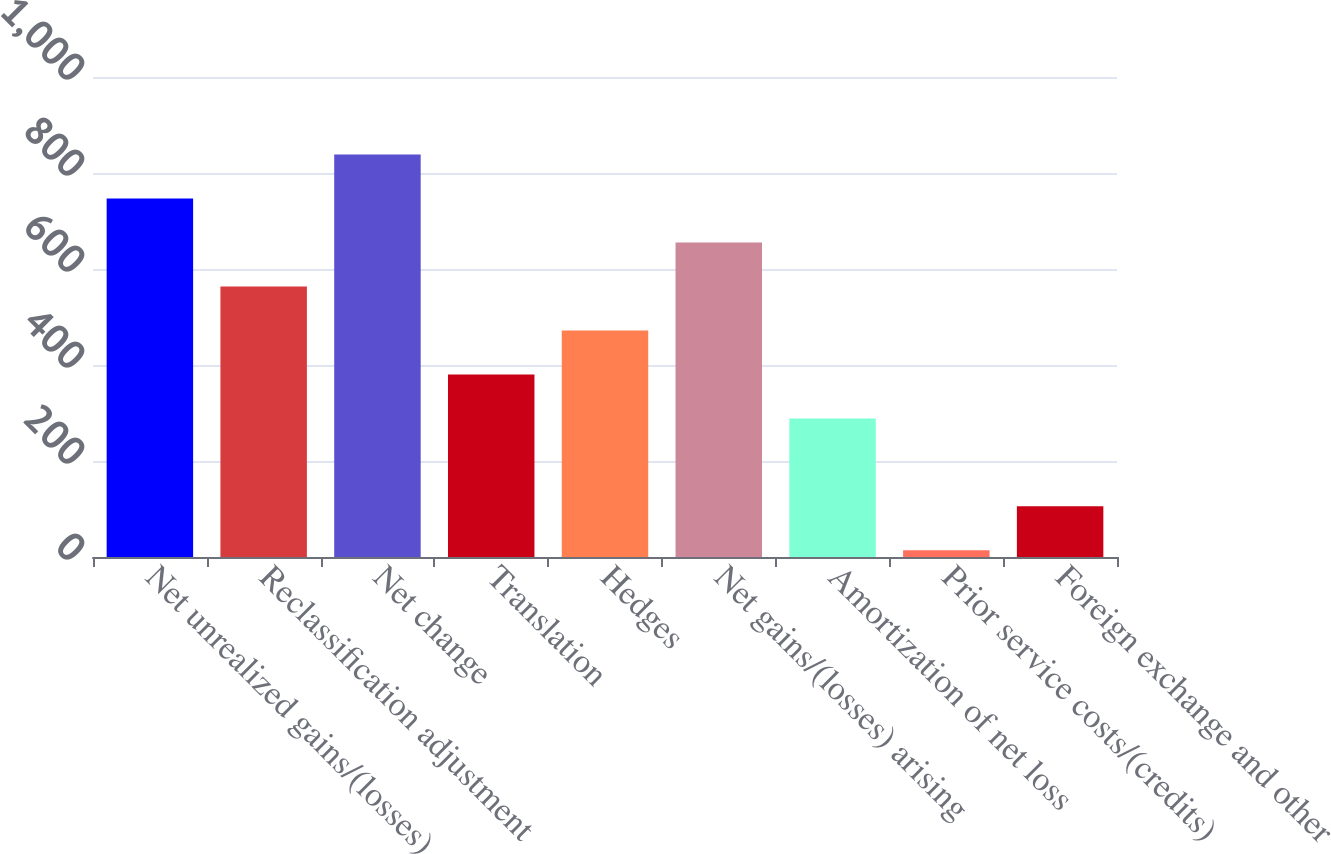Convert chart. <chart><loc_0><loc_0><loc_500><loc_500><bar_chart><fcel>Net unrealized gains/(losses)<fcel>Reclassification adjustment<fcel>Net change<fcel>Translation<fcel>Hedges<fcel>Net gains/(losses) arising<fcel>Amortization of net loss<fcel>Prior service costs/(credits)<fcel>Foreign exchange and other<nl><fcel>746.8<fcel>563.6<fcel>838.4<fcel>380.4<fcel>472<fcel>655.2<fcel>288.8<fcel>14<fcel>105.6<nl></chart> 